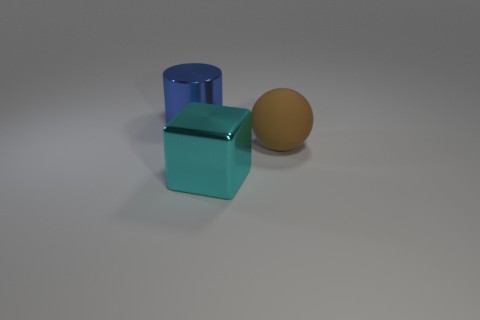Add 1 tiny gray matte blocks. How many objects exist? 4 Subtract all blocks. How many objects are left? 2 Subtract all blue balls. How many yellow cylinders are left? 0 Subtract all small gray rubber spheres. Subtract all large metallic cylinders. How many objects are left? 2 Add 3 metal cubes. How many metal cubes are left? 4 Add 2 tiny blue matte cylinders. How many tiny blue matte cylinders exist? 2 Subtract 0 blue cubes. How many objects are left? 3 